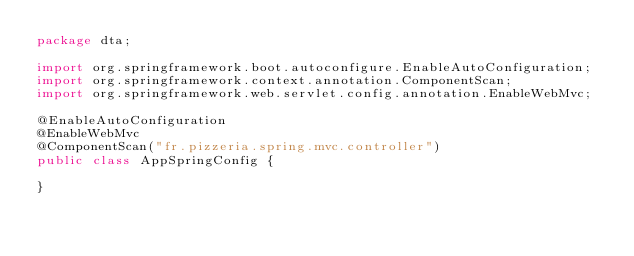<code> <loc_0><loc_0><loc_500><loc_500><_Java_>package dta;

import org.springframework.boot.autoconfigure.EnableAutoConfiguration;
import org.springframework.context.annotation.ComponentScan;
import org.springframework.web.servlet.config.annotation.EnableWebMvc;

@EnableAutoConfiguration
@EnableWebMvc
@ComponentScan("fr.pizzeria.spring.mvc.controller")
public class AppSpringConfig {

}
</code> 